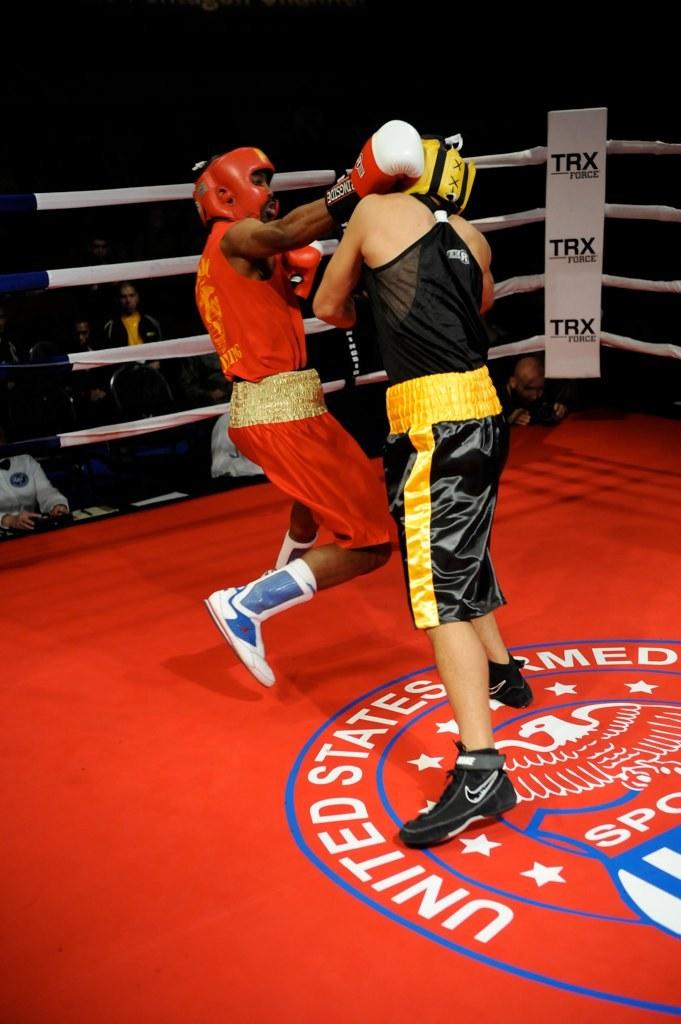What brand name is in the corner?
Provide a succinct answer. Trx. 